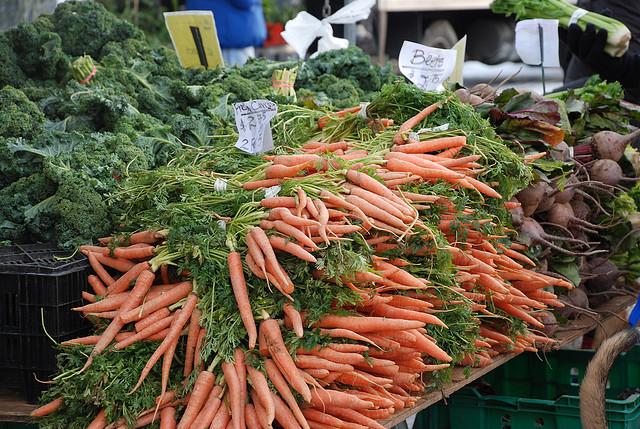Are there a lot of carrots in the picture?
Short answer required. Yes. What is it about this carrot that makes it unique?
Concise answer only. Root. Are carrots high in beta carotene?
Short answer required. Yes. How many different colors do you see on the carrots?
Write a very short answer. 2. Is the fruit ripe?
Be succinct. Yes. Is that sage behind the vegetable?
Quick response, please. No. What color are the carrots?
Short answer required. Orange. How many stalks of carrots are in each bundle?
Keep it brief. 10. How does the dog food taste?
Short answer required. Bad. What kind of fruit is in this scene?
Keep it brief. Carrot. How much are Heirloom Carrots?
Answer briefly. 2.75. 